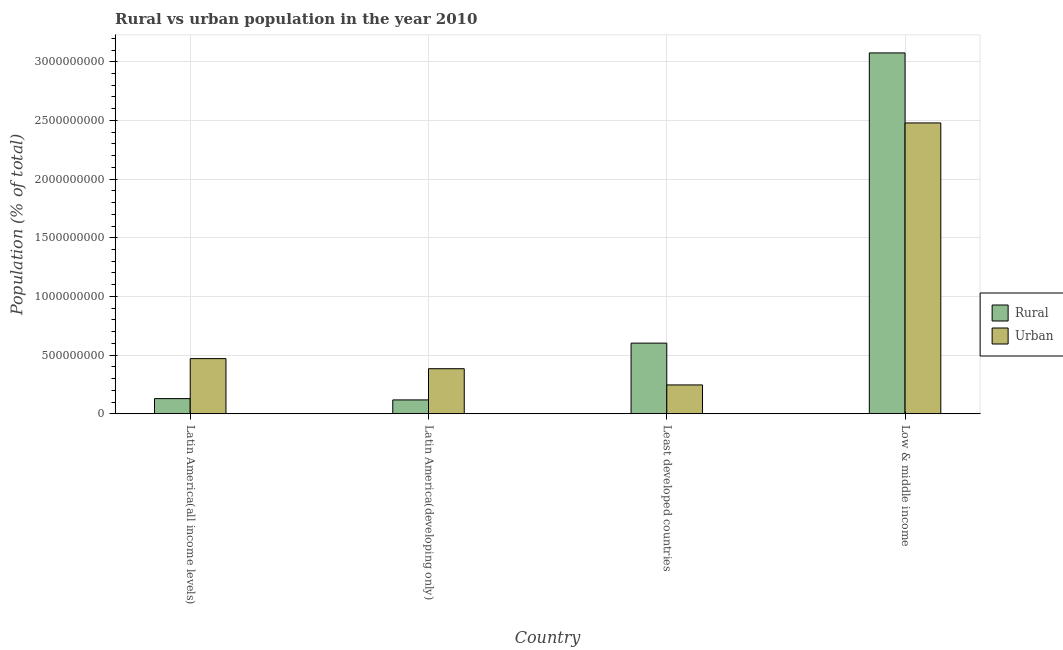How many groups of bars are there?
Give a very brief answer. 4. Are the number of bars on each tick of the X-axis equal?
Provide a succinct answer. Yes. How many bars are there on the 4th tick from the left?
Your answer should be compact. 2. What is the label of the 1st group of bars from the left?
Make the answer very short. Latin America(all income levels). In how many cases, is the number of bars for a given country not equal to the number of legend labels?
Provide a succinct answer. 0. What is the rural population density in Least developed countries?
Your answer should be compact. 6.02e+08. Across all countries, what is the maximum urban population density?
Make the answer very short. 2.48e+09. Across all countries, what is the minimum urban population density?
Provide a succinct answer. 2.45e+08. In which country was the rural population density maximum?
Offer a very short reply. Low & middle income. In which country was the rural population density minimum?
Your answer should be very brief. Latin America(developing only). What is the total rural population density in the graph?
Make the answer very short. 3.92e+09. What is the difference between the urban population density in Latin America(developing only) and that in Least developed countries?
Keep it short and to the point. 1.38e+08. What is the difference between the rural population density in Latin America(all income levels) and the urban population density in Low & middle income?
Make the answer very short. -2.35e+09. What is the average urban population density per country?
Make the answer very short. 8.94e+08. What is the difference between the urban population density and rural population density in Latin America(developing only)?
Offer a terse response. 2.66e+08. What is the ratio of the urban population density in Latin America(developing only) to that in Low & middle income?
Make the answer very short. 0.15. Is the rural population density in Least developed countries less than that in Low & middle income?
Your answer should be compact. Yes. What is the difference between the highest and the second highest urban population density?
Offer a terse response. 2.01e+09. What is the difference between the highest and the lowest urban population density?
Your answer should be compact. 2.23e+09. In how many countries, is the rural population density greater than the average rural population density taken over all countries?
Provide a succinct answer. 1. What does the 1st bar from the left in Latin America(all income levels) represents?
Your answer should be compact. Rural. What does the 2nd bar from the right in Latin America(all income levels) represents?
Offer a terse response. Rural. How many bars are there?
Keep it short and to the point. 8. How many countries are there in the graph?
Keep it short and to the point. 4. Are the values on the major ticks of Y-axis written in scientific E-notation?
Keep it short and to the point. No. Does the graph contain any zero values?
Your answer should be very brief. No. Does the graph contain grids?
Your response must be concise. Yes. How many legend labels are there?
Give a very brief answer. 2. What is the title of the graph?
Make the answer very short. Rural vs urban population in the year 2010. What is the label or title of the Y-axis?
Provide a short and direct response. Population (% of total). What is the Population (% of total) of Rural in Latin America(all income levels)?
Make the answer very short. 1.29e+08. What is the Population (% of total) of Urban in Latin America(all income levels)?
Your answer should be very brief. 4.70e+08. What is the Population (% of total) of Rural in Latin America(developing only)?
Offer a terse response. 1.18e+08. What is the Population (% of total) in Urban in Latin America(developing only)?
Give a very brief answer. 3.84e+08. What is the Population (% of total) of Rural in Least developed countries?
Ensure brevity in your answer.  6.02e+08. What is the Population (% of total) of Urban in Least developed countries?
Your response must be concise. 2.45e+08. What is the Population (% of total) in Rural in Low & middle income?
Make the answer very short. 3.08e+09. What is the Population (% of total) of Urban in Low & middle income?
Provide a succinct answer. 2.48e+09. Across all countries, what is the maximum Population (% of total) of Rural?
Offer a terse response. 3.08e+09. Across all countries, what is the maximum Population (% of total) of Urban?
Make the answer very short. 2.48e+09. Across all countries, what is the minimum Population (% of total) in Rural?
Your response must be concise. 1.18e+08. Across all countries, what is the minimum Population (% of total) in Urban?
Keep it short and to the point. 2.45e+08. What is the total Population (% of total) of Rural in the graph?
Provide a short and direct response. 3.92e+09. What is the total Population (% of total) in Urban in the graph?
Provide a succinct answer. 3.58e+09. What is the difference between the Population (% of total) of Rural in Latin America(all income levels) and that in Latin America(developing only)?
Your response must be concise. 1.10e+07. What is the difference between the Population (% of total) in Urban in Latin America(all income levels) and that in Latin America(developing only)?
Your answer should be very brief. 8.59e+07. What is the difference between the Population (% of total) in Rural in Latin America(all income levels) and that in Least developed countries?
Provide a short and direct response. -4.73e+08. What is the difference between the Population (% of total) in Urban in Latin America(all income levels) and that in Least developed countries?
Give a very brief answer. 2.24e+08. What is the difference between the Population (% of total) in Rural in Latin America(all income levels) and that in Low & middle income?
Offer a very short reply. -2.95e+09. What is the difference between the Population (% of total) in Urban in Latin America(all income levels) and that in Low & middle income?
Provide a succinct answer. -2.01e+09. What is the difference between the Population (% of total) in Rural in Latin America(developing only) and that in Least developed countries?
Keep it short and to the point. -4.84e+08. What is the difference between the Population (% of total) of Urban in Latin America(developing only) and that in Least developed countries?
Ensure brevity in your answer.  1.38e+08. What is the difference between the Population (% of total) in Rural in Latin America(developing only) and that in Low & middle income?
Keep it short and to the point. -2.96e+09. What is the difference between the Population (% of total) of Urban in Latin America(developing only) and that in Low & middle income?
Offer a terse response. -2.09e+09. What is the difference between the Population (% of total) in Rural in Least developed countries and that in Low & middle income?
Offer a very short reply. -2.47e+09. What is the difference between the Population (% of total) in Urban in Least developed countries and that in Low & middle income?
Your answer should be very brief. -2.23e+09. What is the difference between the Population (% of total) of Rural in Latin America(all income levels) and the Population (% of total) of Urban in Latin America(developing only)?
Your answer should be compact. -2.55e+08. What is the difference between the Population (% of total) in Rural in Latin America(all income levels) and the Population (% of total) in Urban in Least developed countries?
Provide a short and direct response. -1.17e+08. What is the difference between the Population (% of total) of Rural in Latin America(all income levels) and the Population (% of total) of Urban in Low & middle income?
Make the answer very short. -2.35e+09. What is the difference between the Population (% of total) in Rural in Latin America(developing only) and the Population (% of total) in Urban in Least developed countries?
Provide a short and direct response. -1.28e+08. What is the difference between the Population (% of total) in Rural in Latin America(developing only) and the Population (% of total) in Urban in Low & middle income?
Make the answer very short. -2.36e+09. What is the difference between the Population (% of total) of Rural in Least developed countries and the Population (% of total) of Urban in Low & middle income?
Make the answer very short. -1.88e+09. What is the average Population (% of total) in Rural per country?
Give a very brief answer. 9.81e+08. What is the average Population (% of total) of Urban per country?
Offer a very short reply. 8.94e+08. What is the difference between the Population (% of total) in Rural and Population (% of total) in Urban in Latin America(all income levels)?
Your answer should be very brief. -3.41e+08. What is the difference between the Population (% of total) in Rural and Population (% of total) in Urban in Latin America(developing only)?
Ensure brevity in your answer.  -2.66e+08. What is the difference between the Population (% of total) in Rural and Population (% of total) in Urban in Least developed countries?
Keep it short and to the point. 3.56e+08. What is the difference between the Population (% of total) in Rural and Population (% of total) in Urban in Low & middle income?
Ensure brevity in your answer.  5.97e+08. What is the ratio of the Population (% of total) in Rural in Latin America(all income levels) to that in Latin America(developing only)?
Your response must be concise. 1.09. What is the ratio of the Population (% of total) of Urban in Latin America(all income levels) to that in Latin America(developing only)?
Your answer should be compact. 1.22. What is the ratio of the Population (% of total) of Rural in Latin America(all income levels) to that in Least developed countries?
Offer a terse response. 0.21. What is the ratio of the Population (% of total) in Urban in Latin America(all income levels) to that in Least developed countries?
Make the answer very short. 1.91. What is the ratio of the Population (% of total) of Rural in Latin America(all income levels) to that in Low & middle income?
Keep it short and to the point. 0.04. What is the ratio of the Population (% of total) in Urban in Latin America(all income levels) to that in Low & middle income?
Ensure brevity in your answer.  0.19. What is the ratio of the Population (% of total) in Rural in Latin America(developing only) to that in Least developed countries?
Offer a terse response. 0.2. What is the ratio of the Population (% of total) in Urban in Latin America(developing only) to that in Least developed countries?
Your answer should be compact. 1.56. What is the ratio of the Population (% of total) of Rural in Latin America(developing only) to that in Low & middle income?
Your response must be concise. 0.04. What is the ratio of the Population (% of total) in Urban in Latin America(developing only) to that in Low & middle income?
Offer a very short reply. 0.15. What is the ratio of the Population (% of total) in Rural in Least developed countries to that in Low & middle income?
Provide a short and direct response. 0.2. What is the ratio of the Population (% of total) in Urban in Least developed countries to that in Low & middle income?
Your response must be concise. 0.1. What is the difference between the highest and the second highest Population (% of total) of Rural?
Keep it short and to the point. 2.47e+09. What is the difference between the highest and the second highest Population (% of total) in Urban?
Your response must be concise. 2.01e+09. What is the difference between the highest and the lowest Population (% of total) of Rural?
Your answer should be very brief. 2.96e+09. What is the difference between the highest and the lowest Population (% of total) of Urban?
Make the answer very short. 2.23e+09. 